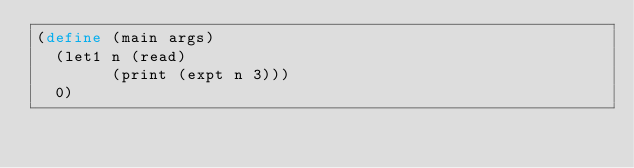Convert code to text. <code><loc_0><loc_0><loc_500><loc_500><_Scheme_>(define (main args)
  (let1 n (read)
        (print (expt n 3)))
  0)
</code> 